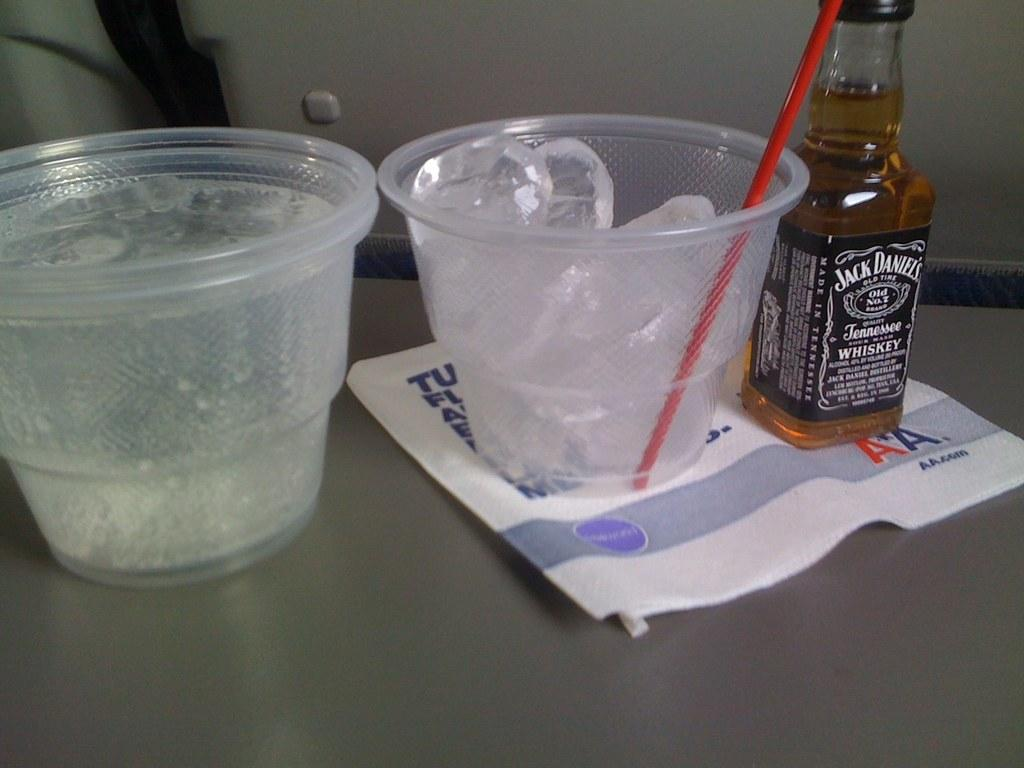<image>
Summarize the visual content of the image. Plastic cup with a straw next to a small bottle of Jack Daniels with napkin stamped with AA. 